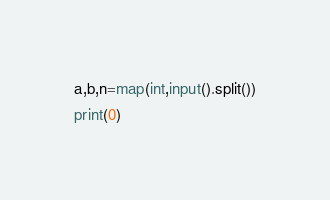<code> <loc_0><loc_0><loc_500><loc_500><_Python_>a,b,n=map(int,input().split())
print(0)</code> 